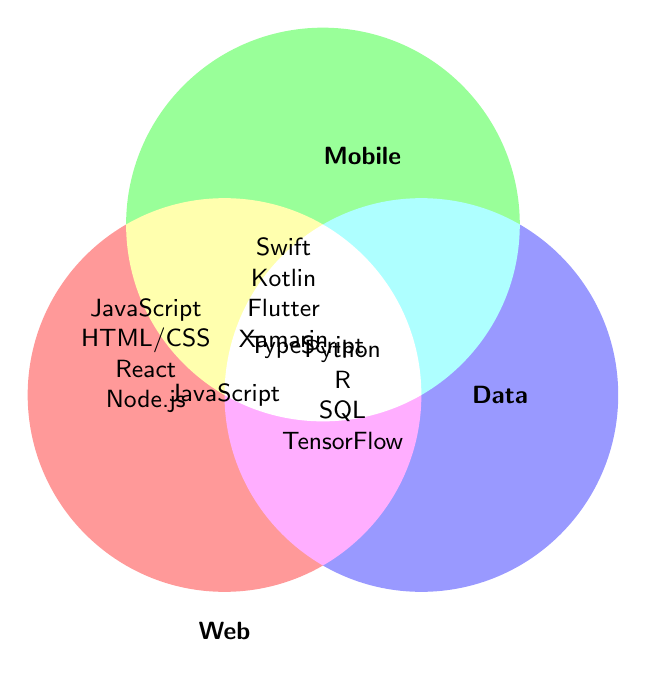What are the languages common to all three fields (Web, Mobile, Data)? The figure shows overlapping areas of the Venn diagram to indicate common languages. The center part where all three circles intersect represents languages used in all three fields.
Answer: JavaScript Which languages are exclusive to Web Development? The left circle represents Web Development; languages listed within this circle but not overlapping with others are exclusive to Web Development.
Answer: HTML/CSS, Node.js, React, Vue.js Which fields use Swift? By locating Swift within the Venn diagram, we find it in the Mobile circle, which does not overlap with others.
Answer: Mobile Development Is Python used in Mobile Development? Python is located in the Data Science circle but not in the Mobile circle.
Answer: No Which language is used in both Web Development and Data Science? To determine overlap between Web Development and Data Science, check the intersection of the left and right circles. The language listed here is TypeScript.
Answer: TypeScript How many languages are used exclusively for Data Science? The right circle represents Data Science. Counting the languages inside this circle that do not overlap with others provides the answer.
Answer: 5 What is the total number of unique languages mentioned in the diagram? Count all the individual languages, considering each one only once, even if it appears in multiple sections.
Answer: 14 Which fields have React as a common programming language? React is positioned within the left and middle circles, indicating it is shared between Web Development and Mobile Development.
Answer: Web Development and Mobile Development How many programming languages overlap between Web Development and Mobile Development? Visually check the intersection area between the left and middle circles and count the languages listed.
Answer: 1 Which programming languages are used in exactly two fields and what are these fields? Find languages situated only in areas where two circles intersect but not three. Identify the fields by observing the circles they appear in. TypeScript (Web Development and Data Science) and JavaScript (Web Development and Mobile Development) satisfy this.
Answer: JavaScript (Web, Mobile), TypeScript (Web, Data) 